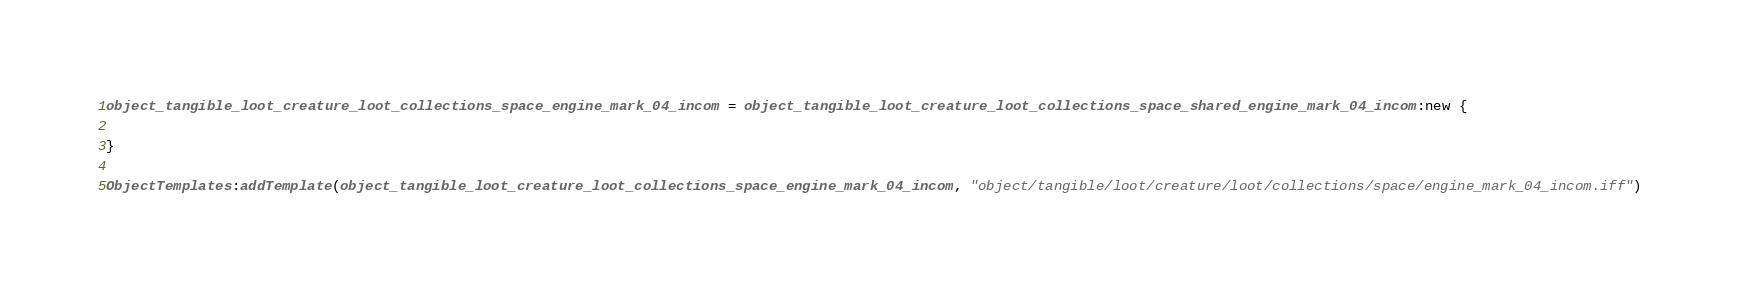<code> <loc_0><loc_0><loc_500><loc_500><_Lua_>object_tangible_loot_creature_loot_collections_space_engine_mark_04_incom = object_tangible_loot_creature_loot_collections_space_shared_engine_mark_04_incom:new {

}

ObjectTemplates:addTemplate(object_tangible_loot_creature_loot_collections_space_engine_mark_04_incom, "object/tangible/loot/creature/loot/collections/space/engine_mark_04_incom.iff")
</code> 